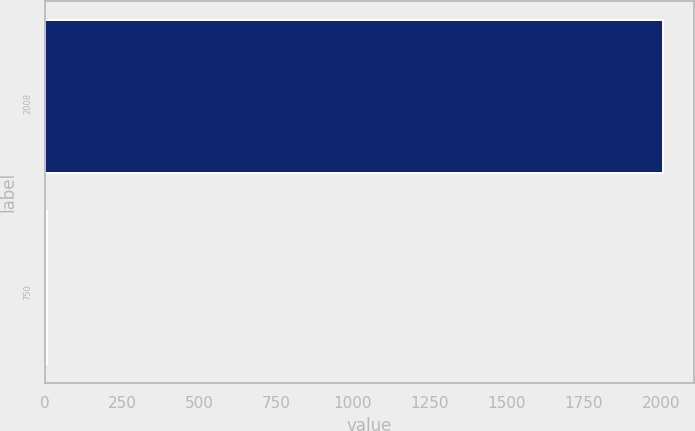Convert chart to OTSL. <chart><loc_0><loc_0><loc_500><loc_500><bar_chart><fcel>2008<fcel>750<nl><fcel>2007<fcel>6.5<nl></chart> 